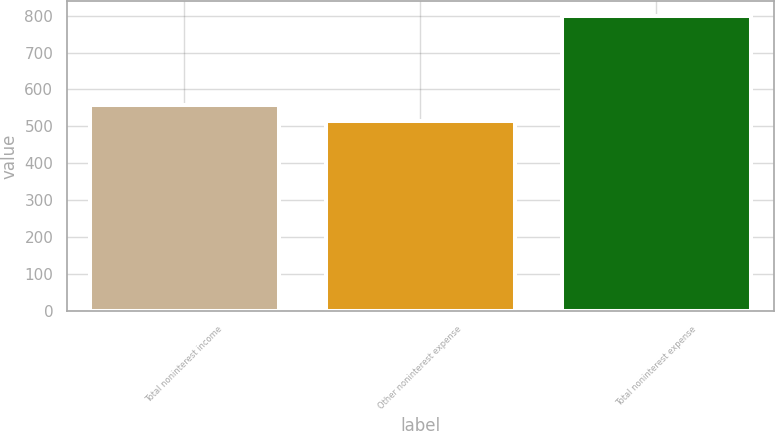Convert chart. <chart><loc_0><loc_0><loc_500><loc_500><bar_chart><fcel>Total noninterest income<fcel>Other noninterest expense<fcel>Total noninterest expense<nl><fcel>558<fcel>514<fcel>800<nl></chart> 